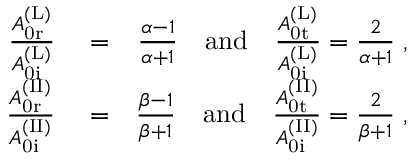Convert formula to latex. <formula><loc_0><loc_0><loc_500><loc_500>\begin{array} { r l r } { \frac { A _ { 0 r } ^ { ( L ) } } { A _ { 0 i } ^ { ( L ) } } } & = } & { \frac { \alpha - 1 } { \alpha + 1 } \quad a n d \quad \frac { A _ { 0 t } ^ { ( L ) } } { A _ { 0 i } ^ { ( L ) } } = \frac { 2 } { \alpha + 1 } \, , } \\ { \frac { A _ { 0 r } ^ { ( I I ) } } { A _ { 0 i } ^ { ( I I ) } } } & = } & { \frac { \beta - 1 } { \beta + 1 } \quad a n d \quad \frac { A _ { 0 t } ^ { ( I I ) } } { A _ { 0 i } ^ { ( I I ) } } = \frac { 2 } { \beta + 1 } \, , } \end{array}</formula> 